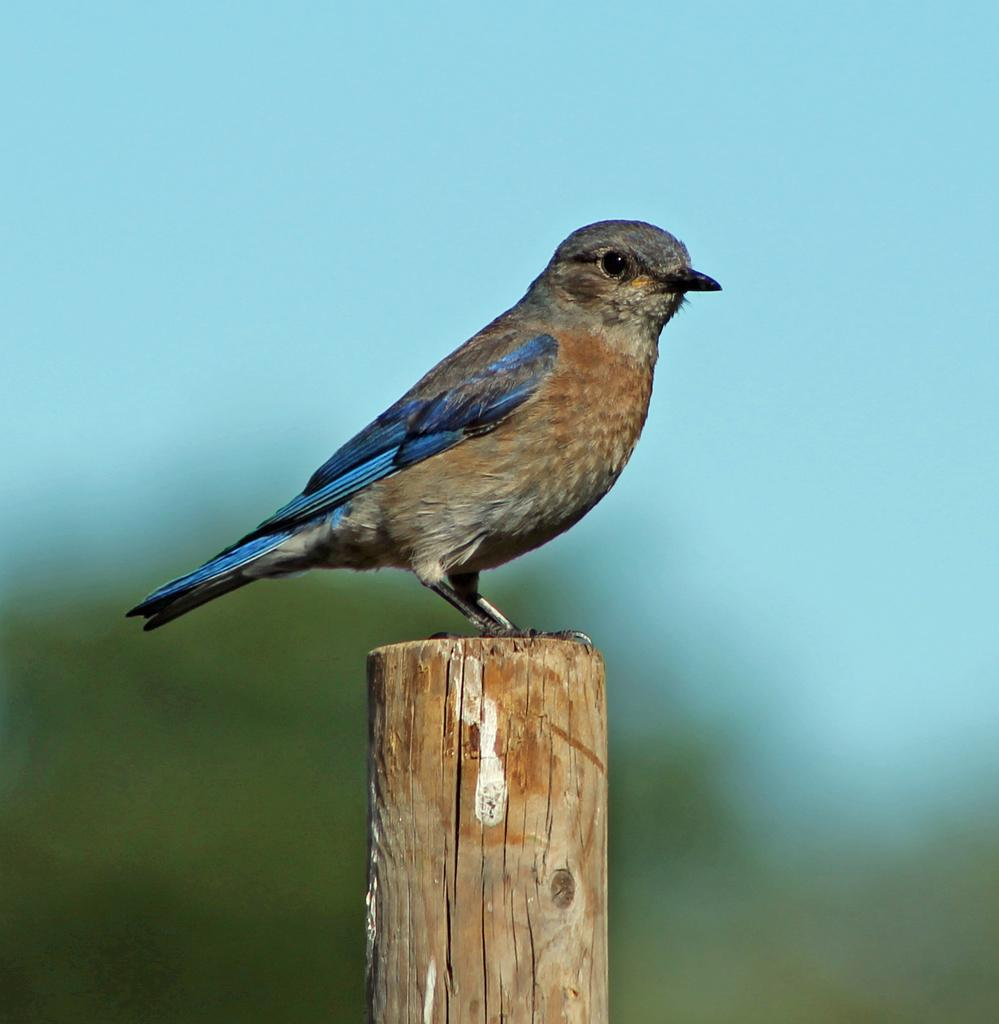What type of animal can be seen in the image? There is a bird in the image. What is the bird standing on? The bird is standing on a wooden pole. What can be seen in the background of the image? There are plants and the sky visible in the background of the image. What type of drum is the bird playing in the image? There is no drum present in the image; it features a bird standing on a wooden pole. How many lettuce leaves can be seen in the image? There is no lettuce present in the image; it features a bird standing on a wooden pole with plants in the background. 